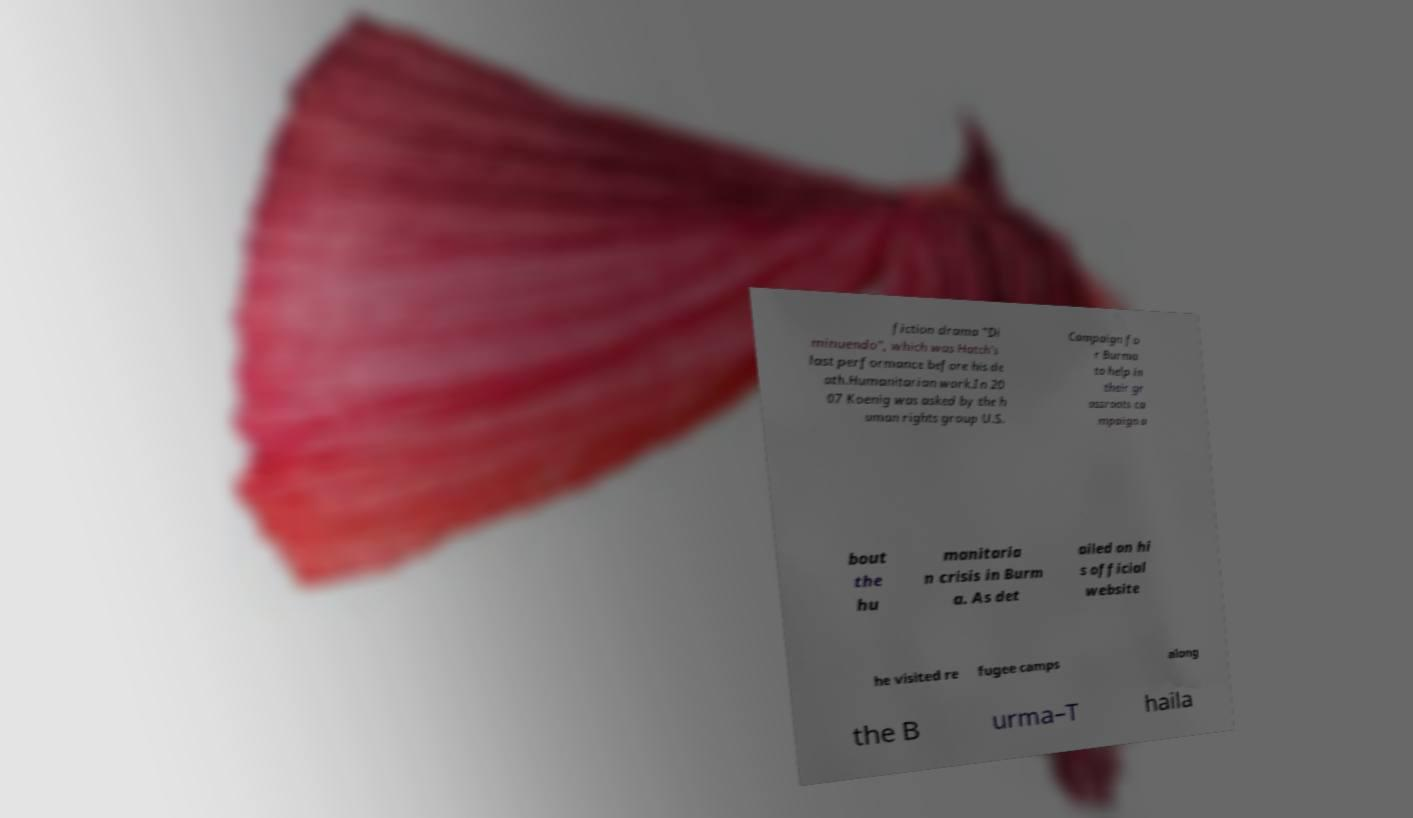What messages or text are displayed in this image? I need them in a readable, typed format. fiction drama "Di minuendo", which was Hatch's last performance before his de ath.Humanitarian work.In 20 07 Koenig was asked by the h uman rights group U.S. Campaign fo r Burma to help in their gr assroots ca mpaign a bout the hu manitaria n crisis in Burm a. As det ailed on hi s official website he visited re fugee camps along the B urma–T haila 